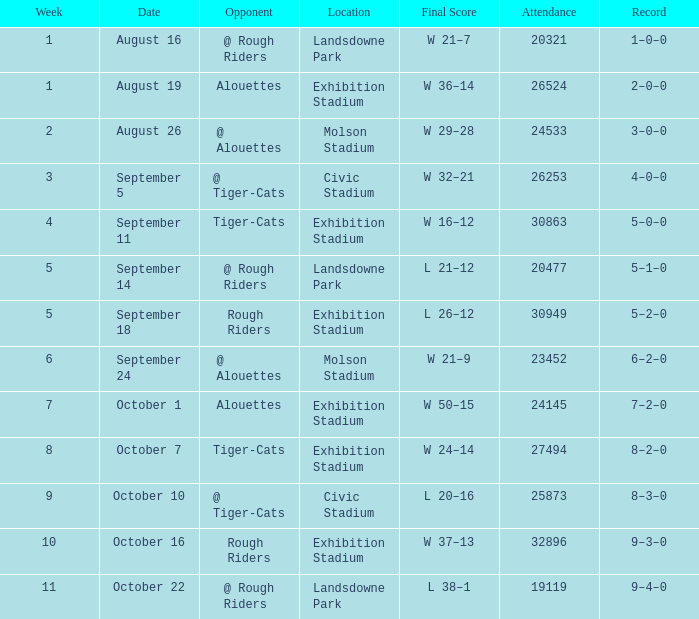Parse the table in full. {'header': ['Week', 'Date', 'Opponent', 'Location', 'Final Score', 'Attendance', 'Record'], 'rows': [['1', 'August 16', '@ Rough Riders', 'Landsdowne Park', 'W 21–7', '20321', '1–0–0'], ['1', 'August 19', 'Alouettes', 'Exhibition Stadium', 'W 36–14', '26524', '2–0–0'], ['2', 'August 26', '@ Alouettes', 'Molson Stadium', 'W 29–28', '24533', '3–0–0'], ['3', 'September 5', '@ Tiger-Cats', 'Civic Stadium', 'W 32–21', '26253', '4–0–0'], ['4', 'September 11', 'Tiger-Cats', 'Exhibition Stadium', 'W 16–12', '30863', '5–0–0'], ['5', 'September 14', '@ Rough Riders', 'Landsdowne Park', 'L 21–12', '20477', '5–1–0'], ['5', 'September 18', 'Rough Riders', 'Exhibition Stadium', 'L 26–12', '30949', '5–2–0'], ['6', 'September 24', '@ Alouettes', 'Molson Stadium', 'W 21–9', '23452', '6–2–0'], ['7', 'October 1', 'Alouettes', 'Exhibition Stadium', 'W 50–15', '24145', '7–2–0'], ['8', 'October 7', 'Tiger-Cats', 'Exhibition Stadium', 'W 24–14', '27494', '8–2–0'], ['9', 'October 10', '@ Tiger-Cats', 'Civic Stadium', 'L 20–16', '25873', '8–3–0'], ['10', 'October 16', 'Rough Riders', 'Exhibition Stadium', 'W 37–13', '32896', '9–3–0'], ['11', 'October 22', '@ Rough Riders', 'Landsdowne Park', 'L 38–1', '19119', '9–4–0']]} How many values for attendance on the date of August 26? 1.0. 